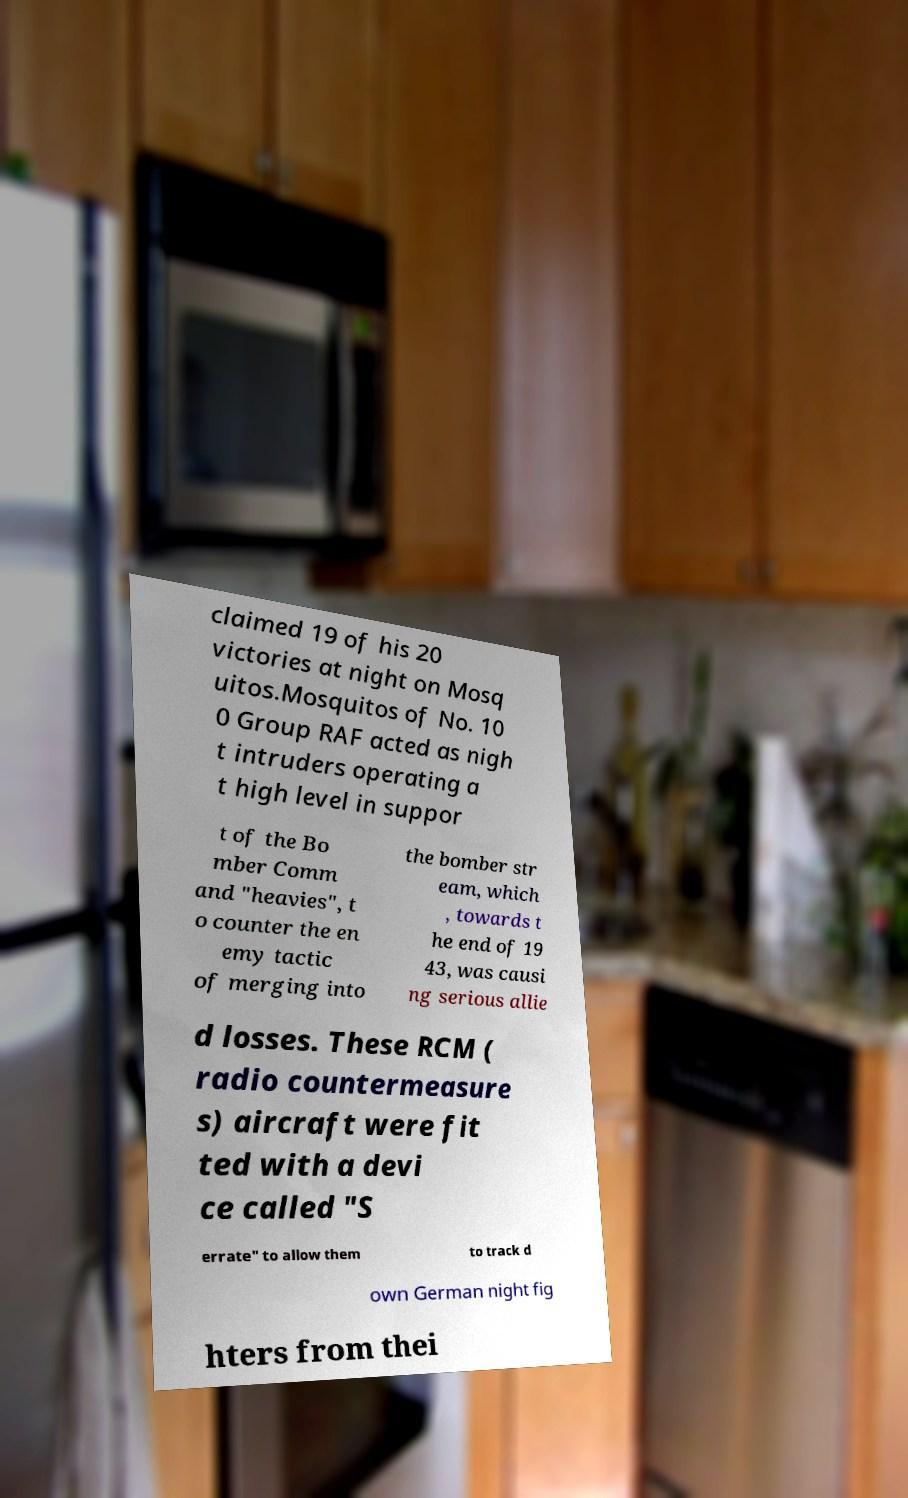Please identify and transcribe the text found in this image. claimed 19 of his 20 victories at night on Mosq uitos.Mosquitos of No. 10 0 Group RAF acted as nigh t intruders operating a t high level in suppor t of the Bo mber Comm and "heavies", t o counter the en emy tactic of merging into the bomber str eam, which , towards t he end of 19 43, was causi ng serious allie d losses. These RCM ( radio countermeasure s) aircraft were fit ted with a devi ce called "S errate" to allow them to track d own German night fig hters from thei 